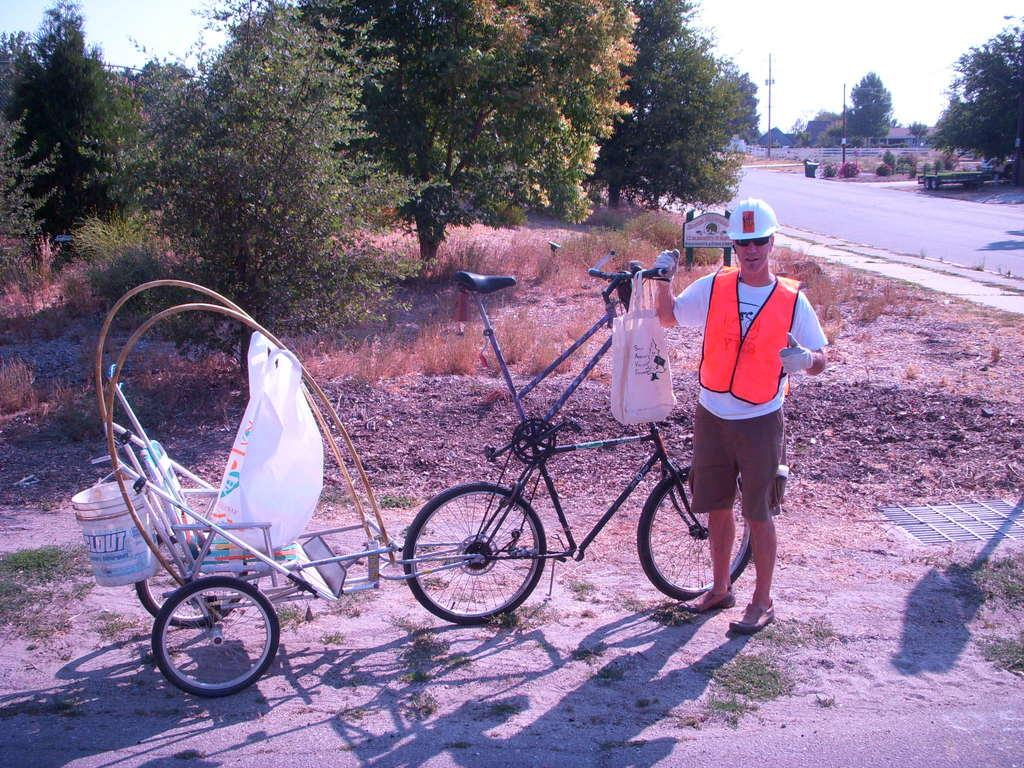What is the person in the image doing? The person is standing at the bottom of the image and holding a bicycle. What can be seen in the background of the image? There are trees in the background of the image. What is on the right side of the image? There is a road on the right side of the image. How many marbles are scattered on the road in the image? There are no marbles present in the image; it only shows a person holding a bicycle, trees in the background, and a road on the right side. 